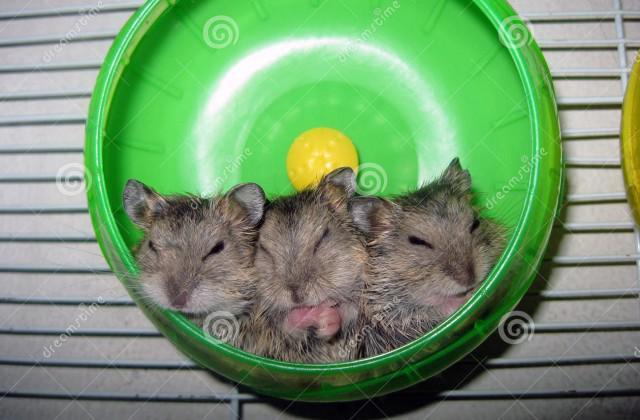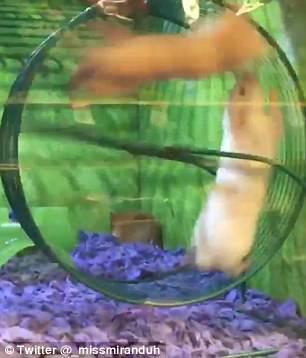The first image is the image on the left, the second image is the image on the right. Given the left and right images, does the statement "In one of the images, three hamsters are huddled together in a small space." hold true? Answer yes or no. Yes. 